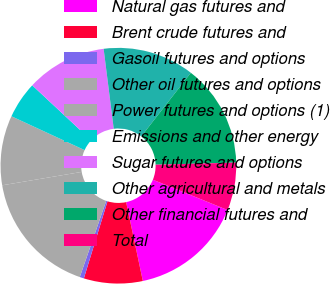<chart> <loc_0><loc_0><loc_500><loc_500><pie_chart><fcel>Natural gas futures and<fcel>Brent crude futures and<fcel>Gasoil futures and options<fcel>Other oil futures and options<fcel>Power futures and options (1)<fcel>Emissions and other energy<fcel>Sugar futures and options<fcel>Other agricultural and metals<fcel>Other financial futures and<fcel>Total<nl><fcel>15.54%<fcel>8.06%<fcel>0.58%<fcel>17.03%<fcel>9.55%<fcel>5.06%<fcel>11.05%<fcel>12.54%<fcel>14.04%<fcel>6.56%<nl></chart> 